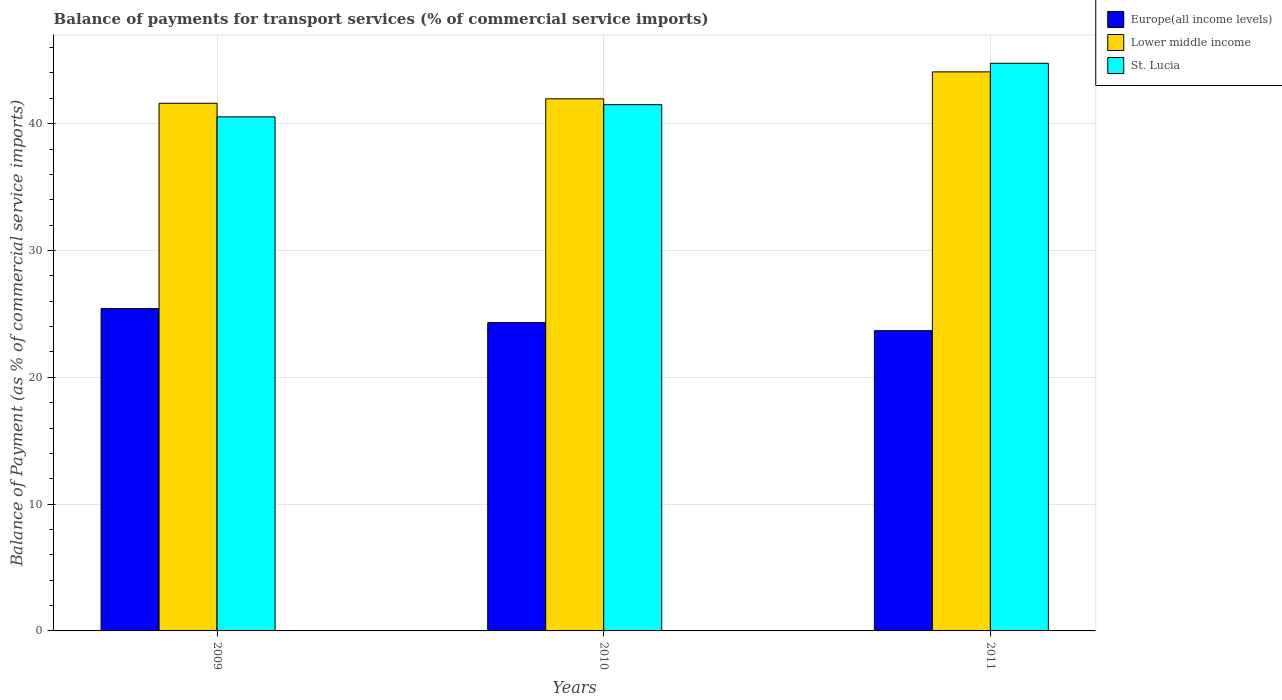How many different coloured bars are there?
Provide a short and direct response. 3. How many groups of bars are there?
Offer a terse response. 3. Are the number of bars per tick equal to the number of legend labels?
Your answer should be compact. Yes. How many bars are there on the 3rd tick from the right?
Give a very brief answer. 3. What is the balance of payments for transport services in St. Lucia in 2010?
Your response must be concise. 41.5. Across all years, what is the maximum balance of payments for transport services in St. Lucia?
Your response must be concise. 44.77. Across all years, what is the minimum balance of payments for transport services in Lower middle income?
Offer a very short reply. 41.61. In which year was the balance of payments for transport services in St. Lucia maximum?
Your response must be concise. 2011. In which year was the balance of payments for transport services in Lower middle income minimum?
Make the answer very short. 2009. What is the total balance of payments for transport services in Lower middle income in the graph?
Provide a short and direct response. 127.66. What is the difference between the balance of payments for transport services in St. Lucia in 2010 and that in 2011?
Your answer should be very brief. -3.27. What is the difference between the balance of payments for transport services in Lower middle income in 2010 and the balance of payments for transport services in Europe(all income levels) in 2009?
Keep it short and to the point. 16.54. What is the average balance of payments for transport services in St. Lucia per year?
Offer a terse response. 42.27. In the year 2010, what is the difference between the balance of payments for transport services in Europe(all income levels) and balance of payments for transport services in St. Lucia?
Ensure brevity in your answer.  -17.19. What is the ratio of the balance of payments for transport services in St. Lucia in 2009 to that in 2010?
Keep it short and to the point. 0.98. What is the difference between the highest and the second highest balance of payments for transport services in St. Lucia?
Your answer should be very brief. 3.27. What is the difference between the highest and the lowest balance of payments for transport services in Lower middle income?
Give a very brief answer. 2.47. Is the sum of the balance of payments for transport services in Europe(all income levels) in 2010 and 2011 greater than the maximum balance of payments for transport services in St. Lucia across all years?
Give a very brief answer. Yes. What does the 3rd bar from the left in 2011 represents?
Provide a short and direct response. St. Lucia. What does the 3rd bar from the right in 2009 represents?
Keep it short and to the point. Europe(all income levels). Is it the case that in every year, the sum of the balance of payments for transport services in St. Lucia and balance of payments for transport services in Europe(all income levels) is greater than the balance of payments for transport services in Lower middle income?
Offer a terse response. Yes. How many bars are there?
Offer a terse response. 9. How many years are there in the graph?
Your answer should be compact. 3. Are the values on the major ticks of Y-axis written in scientific E-notation?
Your answer should be compact. No. Does the graph contain any zero values?
Provide a short and direct response. No. Where does the legend appear in the graph?
Make the answer very short. Top right. How many legend labels are there?
Provide a short and direct response. 3. What is the title of the graph?
Make the answer very short. Balance of payments for transport services (% of commercial service imports). What is the label or title of the Y-axis?
Offer a terse response. Balance of Payment (as % of commercial service imports). What is the Balance of Payment (as % of commercial service imports) of Europe(all income levels) in 2009?
Offer a very short reply. 25.42. What is the Balance of Payment (as % of commercial service imports) of Lower middle income in 2009?
Your response must be concise. 41.61. What is the Balance of Payment (as % of commercial service imports) of St. Lucia in 2009?
Offer a very short reply. 40.54. What is the Balance of Payment (as % of commercial service imports) of Europe(all income levels) in 2010?
Provide a short and direct response. 24.31. What is the Balance of Payment (as % of commercial service imports) in Lower middle income in 2010?
Provide a short and direct response. 41.96. What is the Balance of Payment (as % of commercial service imports) of St. Lucia in 2010?
Ensure brevity in your answer.  41.5. What is the Balance of Payment (as % of commercial service imports) in Europe(all income levels) in 2011?
Keep it short and to the point. 23.68. What is the Balance of Payment (as % of commercial service imports) in Lower middle income in 2011?
Offer a terse response. 44.09. What is the Balance of Payment (as % of commercial service imports) in St. Lucia in 2011?
Your response must be concise. 44.77. Across all years, what is the maximum Balance of Payment (as % of commercial service imports) of Europe(all income levels)?
Your answer should be very brief. 25.42. Across all years, what is the maximum Balance of Payment (as % of commercial service imports) in Lower middle income?
Your response must be concise. 44.09. Across all years, what is the maximum Balance of Payment (as % of commercial service imports) in St. Lucia?
Ensure brevity in your answer.  44.77. Across all years, what is the minimum Balance of Payment (as % of commercial service imports) of Europe(all income levels)?
Your response must be concise. 23.68. Across all years, what is the minimum Balance of Payment (as % of commercial service imports) of Lower middle income?
Keep it short and to the point. 41.61. Across all years, what is the minimum Balance of Payment (as % of commercial service imports) in St. Lucia?
Your answer should be compact. 40.54. What is the total Balance of Payment (as % of commercial service imports) of Europe(all income levels) in the graph?
Ensure brevity in your answer.  73.41. What is the total Balance of Payment (as % of commercial service imports) of Lower middle income in the graph?
Your response must be concise. 127.66. What is the total Balance of Payment (as % of commercial service imports) in St. Lucia in the graph?
Give a very brief answer. 126.8. What is the difference between the Balance of Payment (as % of commercial service imports) of Europe(all income levels) in 2009 and that in 2010?
Provide a succinct answer. 1.1. What is the difference between the Balance of Payment (as % of commercial service imports) in Lower middle income in 2009 and that in 2010?
Your answer should be compact. -0.35. What is the difference between the Balance of Payment (as % of commercial service imports) in St. Lucia in 2009 and that in 2010?
Offer a terse response. -0.96. What is the difference between the Balance of Payment (as % of commercial service imports) in Europe(all income levels) in 2009 and that in 2011?
Provide a succinct answer. 1.74. What is the difference between the Balance of Payment (as % of commercial service imports) in Lower middle income in 2009 and that in 2011?
Ensure brevity in your answer.  -2.47. What is the difference between the Balance of Payment (as % of commercial service imports) of St. Lucia in 2009 and that in 2011?
Your response must be concise. -4.23. What is the difference between the Balance of Payment (as % of commercial service imports) of Europe(all income levels) in 2010 and that in 2011?
Keep it short and to the point. 0.64. What is the difference between the Balance of Payment (as % of commercial service imports) of Lower middle income in 2010 and that in 2011?
Your answer should be compact. -2.12. What is the difference between the Balance of Payment (as % of commercial service imports) in St. Lucia in 2010 and that in 2011?
Provide a short and direct response. -3.27. What is the difference between the Balance of Payment (as % of commercial service imports) of Europe(all income levels) in 2009 and the Balance of Payment (as % of commercial service imports) of Lower middle income in 2010?
Your response must be concise. -16.54. What is the difference between the Balance of Payment (as % of commercial service imports) of Europe(all income levels) in 2009 and the Balance of Payment (as % of commercial service imports) of St. Lucia in 2010?
Provide a short and direct response. -16.08. What is the difference between the Balance of Payment (as % of commercial service imports) of Europe(all income levels) in 2009 and the Balance of Payment (as % of commercial service imports) of Lower middle income in 2011?
Your answer should be compact. -18.67. What is the difference between the Balance of Payment (as % of commercial service imports) of Europe(all income levels) in 2009 and the Balance of Payment (as % of commercial service imports) of St. Lucia in 2011?
Your response must be concise. -19.35. What is the difference between the Balance of Payment (as % of commercial service imports) in Lower middle income in 2009 and the Balance of Payment (as % of commercial service imports) in St. Lucia in 2011?
Provide a succinct answer. -3.15. What is the difference between the Balance of Payment (as % of commercial service imports) in Europe(all income levels) in 2010 and the Balance of Payment (as % of commercial service imports) in Lower middle income in 2011?
Your answer should be compact. -19.77. What is the difference between the Balance of Payment (as % of commercial service imports) of Europe(all income levels) in 2010 and the Balance of Payment (as % of commercial service imports) of St. Lucia in 2011?
Your answer should be compact. -20.45. What is the difference between the Balance of Payment (as % of commercial service imports) of Lower middle income in 2010 and the Balance of Payment (as % of commercial service imports) of St. Lucia in 2011?
Your answer should be compact. -2.8. What is the average Balance of Payment (as % of commercial service imports) of Europe(all income levels) per year?
Offer a very short reply. 24.47. What is the average Balance of Payment (as % of commercial service imports) of Lower middle income per year?
Offer a terse response. 42.55. What is the average Balance of Payment (as % of commercial service imports) of St. Lucia per year?
Ensure brevity in your answer.  42.27. In the year 2009, what is the difference between the Balance of Payment (as % of commercial service imports) in Europe(all income levels) and Balance of Payment (as % of commercial service imports) in Lower middle income?
Offer a terse response. -16.19. In the year 2009, what is the difference between the Balance of Payment (as % of commercial service imports) of Europe(all income levels) and Balance of Payment (as % of commercial service imports) of St. Lucia?
Ensure brevity in your answer.  -15.12. In the year 2009, what is the difference between the Balance of Payment (as % of commercial service imports) of Lower middle income and Balance of Payment (as % of commercial service imports) of St. Lucia?
Offer a terse response. 1.07. In the year 2010, what is the difference between the Balance of Payment (as % of commercial service imports) of Europe(all income levels) and Balance of Payment (as % of commercial service imports) of Lower middle income?
Your answer should be very brief. -17.65. In the year 2010, what is the difference between the Balance of Payment (as % of commercial service imports) in Europe(all income levels) and Balance of Payment (as % of commercial service imports) in St. Lucia?
Keep it short and to the point. -17.19. In the year 2010, what is the difference between the Balance of Payment (as % of commercial service imports) of Lower middle income and Balance of Payment (as % of commercial service imports) of St. Lucia?
Your response must be concise. 0.46. In the year 2011, what is the difference between the Balance of Payment (as % of commercial service imports) in Europe(all income levels) and Balance of Payment (as % of commercial service imports) in Lower middle income?
Your response must be concise. -20.41. In the year 2011, what is the difference between the Balance of Payment (as % of commercial service imports) in Europe(all income levels) and Balance of Payment (as % of commercial service imports) in St. Lucia?
Ensure brevity in your answer.  -21.09. In the year 2011, what is the difference between the Balance of Payment (as % of commercial service imports) of Lower middle income and Balance of Payment (as % of commercial service imports) of St. Lucia?
Offer a very short reply. -0.68. What is the ratio of the Balance of Payment (as % of commercial service imports) in Europe(all income levels) in 2009 to that in 2010?
Your response must be concise. 1.05. What is the ratio of the Balance of Payment (as % of commercial service imports) in Lower middle income in 2009 to that in 2010?
Your answer should be very brief. 0.99. What is the ratio of the Balance of Payment (as % of commercial service imports) of St. Lucia in 2009 to that in 2010?
Ensure brevity in your answer.  0.98. What is the ratio of the Balance of Payment (as % of commercial service imports) in Europe(all income levels) in 2009 to that in 2011?
Provide a succinct answer. 1.07. What is the ratio of the Balance of Payment (as % of commercial service imports) of Lower middle income in 2009 to that in 2011?
Your response must be concise. 0.94. What is the ratio of the Balance of Payment (as % of commercial service imports) of St. Lucia in 2009 to that in 2011?
Provide a short and direct response. 0.91. What is the ratio of the Balance of Payment (as % of commercial service imports) in Europe(all income levels) in 2010 to that in 2011?
Make the answer very short. 1.03. What is the ratio of the Balance of Payment (as % of commercial service imports) of Lower middle income in 2010 to that in 2011?
Your answer should be compact. 0.95. What is the ratio of the Balance of Payment (as % of commercial service imports) of St. Lucia in 2010 to that in 2011?
Make the answer very short. 0.93. What is the difference between the highest and the second highest Balance of Payment (as % of commercial service imports) in Europe(all income levels)?
Provide a succinct answer. 1.1. What is the difference between the highest and the second highest Balance of Payment (as % of commercial service imports) in Lower middle income?
Your response must be concise. 2.12. What is the difference between the highest and the second highest Balance of Payment (as % of commercial service imports) in St. Lucia?
Your response must be concise. 3.27. What is the difference between the highest and the lowest Balance of Payment (as % of commercial service imports) of Europe(all income levels)?
Your response must be concise. 1.74. What is the difference between the highest and the lowest Balance of Payment (as % of commercial service imports) in Lower middle income?
Keep it short and to the point. 2.47. What is the difference between the highest and the lowest Balance of Payment (as % of commercial service imports) in St. Lucia?
Offer a very short reply. 4.23. 